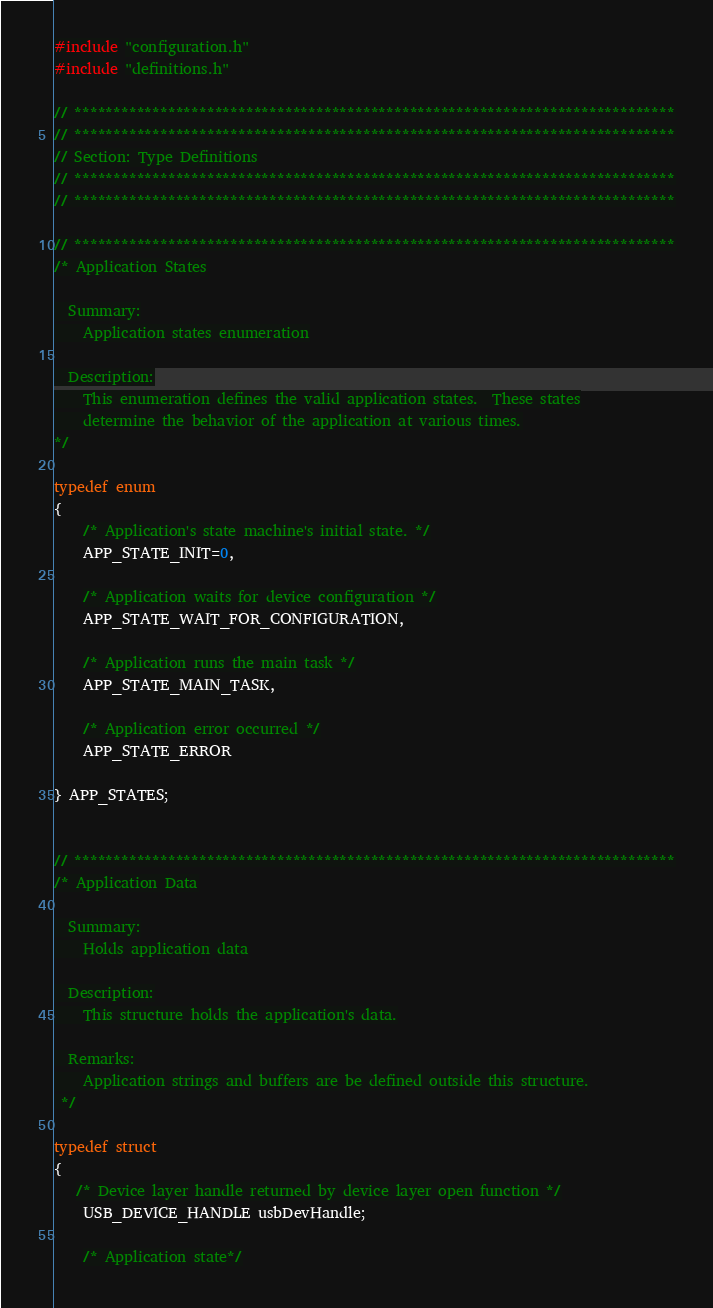<code> <loc_0><loc_0><loc_500><loc_500><_C_>#include "configuration.h"
#include "definitions.h"

// *****************************************************************************
// *****************************************************************************
// Section: Type Definitions
// *****************************************************************************
// *****************************************************************************

// *****************************************************************************
/* Application States

  Summary:
    Application states enumeration

  Description:
    This enumeration defines the valid application states.  These states
    determine the behavior of the application at various times.
*/

typedef enum
{
    /* Application's state machine's initial state. */
    APP_STATE_INIT=0,

    /* Application waits for device configuration */
    APP_STATE_WAIT_FOR_CONFIGURATION,

    /* Application runs the main task */
    APP_STATE_MAIN_TASK,

    /* Application error occurred */
    APP_STATE_ERROR

} APP_STATES;


// *****************************************************************************
/* Application Data

  Summary:
    Holds application data

  Description:
    This structure holds the application's data.

  Remarks:
    Application strings and buffers are be defined outside this structure.
 */

typedef struct
{
   /* Device layer handle returned by device layer open function */
    USB_DEVICE_HANDLE usbDevHandle;

    /* Application state*/</code> 